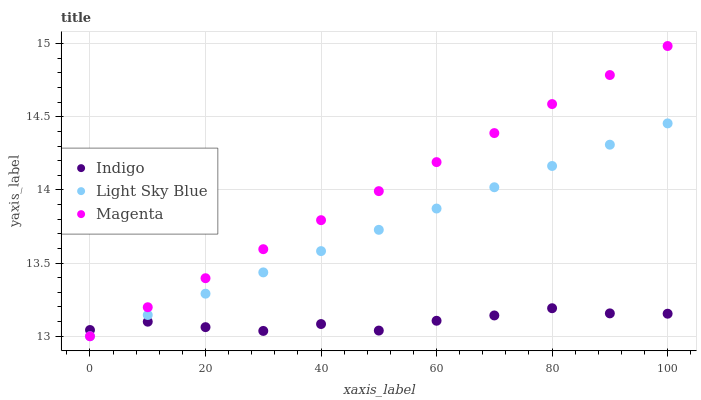Does Indigo have the minimum area under the curve?
Answer yes or no. Yes. Does Magenta have the maximum area under the curve?
Answer yes or no. Yes. Does Light Sky Blue have the minimum area under the curve?
Answer yes or no. No. Does Light Sky Blue have the maximum area under the curve?
Answer yes or no. No. Is Magenta the smoothest?
Answer yes or no. Yes. Is Indigo the roughest?
Answer yes or no. Yes. Is Light Sky Blue the smoothest?
Answer yes or no. No. Is Light Sky Blue the roughest?
Answer yes or no. No. Does Magenta have the lowest value?
Answer yes or no. Yes. Does Indigo have the lowest value?
Answer yes or no. No. Does Magenta have the highest value?
Answer yes or no. Yes. Does Light Sky Blue have the highest value?
Answer yes or no. No. Does Magenta intersect Indigo?
Answer yes or no. Yes. Is Magenta less than Indigo?
Answer yes or no. No. Is Magenta greater than Indigo?
Answer yes or no. No. 